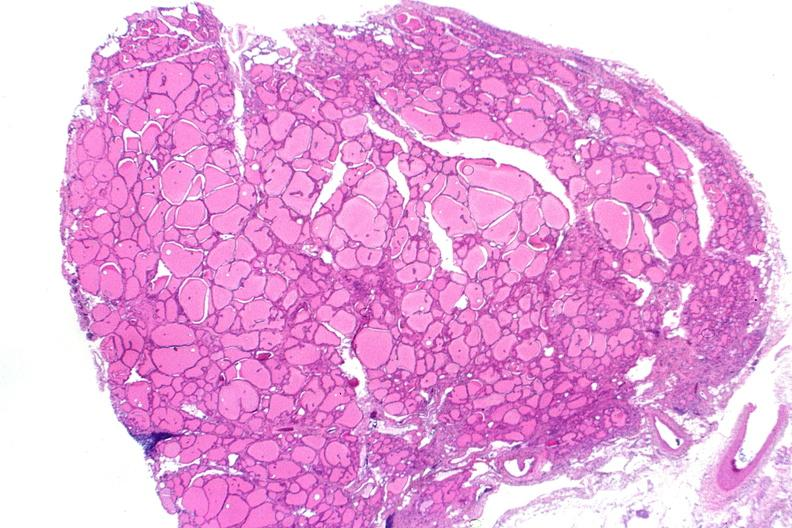where is this part in the figure?
Answer the question using a single word or phrase. Endocrine system 